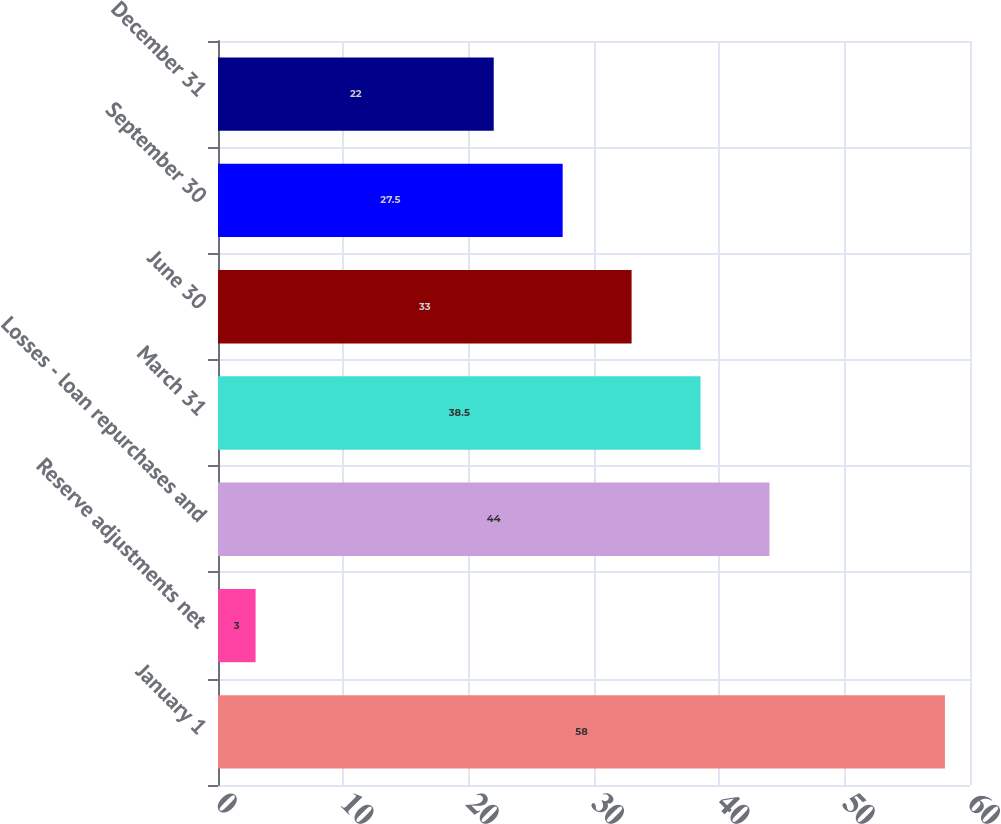Convert chart. <chart><loc_0><loc_0><loc_500><loc_500><bar_chart><fcel>January 1<fcel>Reserve adjustments net<fcel>Losses - loan repurchases and<fcel>March 31<fcel>June 30<fcel>September 30<fcel>December 31<nl><fcel>58<fcel>3<fcel>44<fcel>38.5<fcel>33<fcel>27.5<fcel>22<nl></chart> 